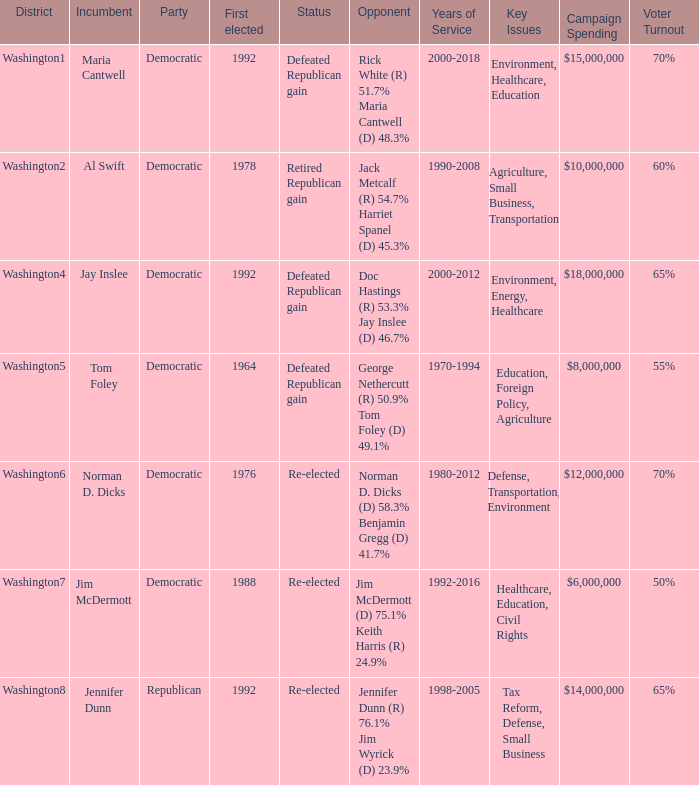What year was incumbent jim mcdermott first elected? 1988.0. 